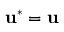<formula> <loc_0><loc_0><loc_500><loc_500>u ^ { * } = u</formula> 